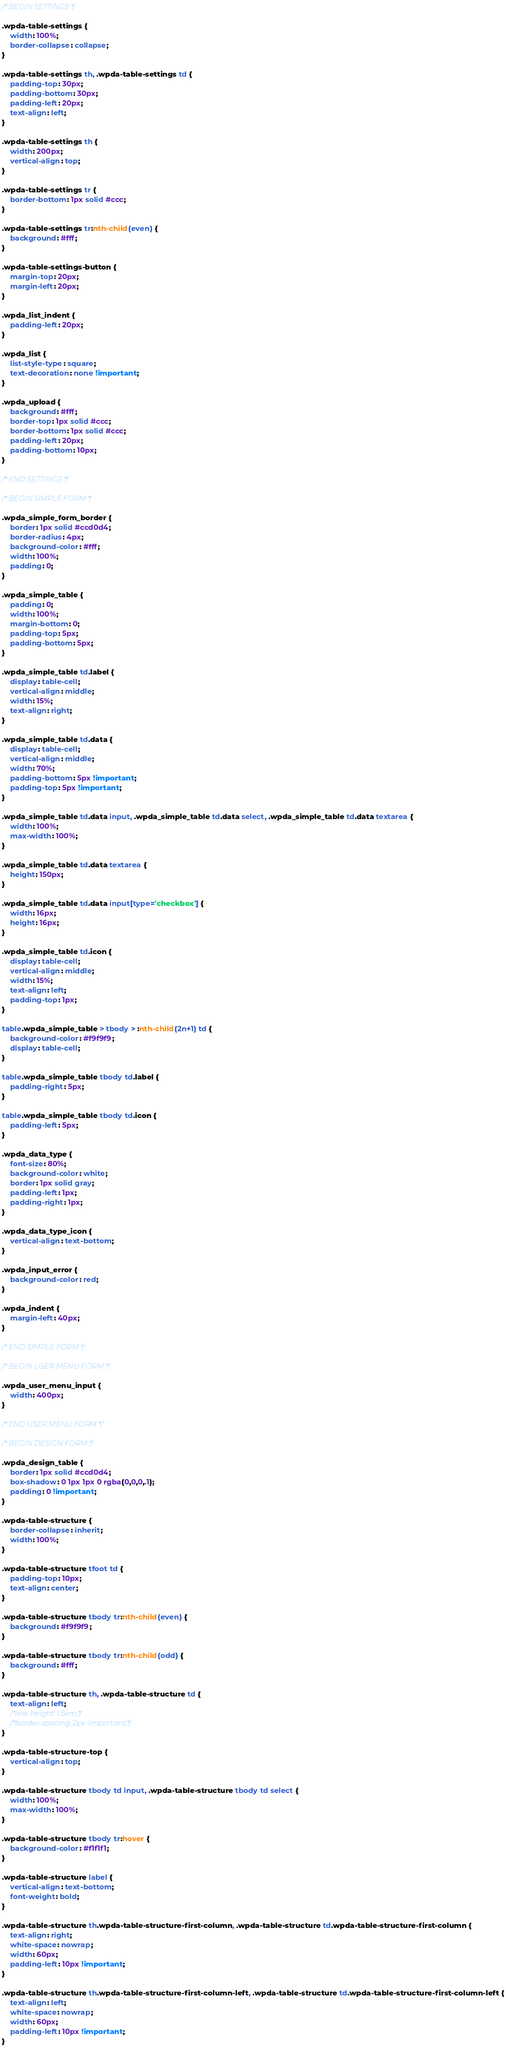Convert code to text. <code><loc_0><loc_0><loc_500><loc_500><_CSS_>/* BEGIN SETTINGS */

.wpda-table-settings {
    width: 100%;
    border-collapse: collapse;
}

.wpda-table-settings th, .wpda-table-settings td {
    padding-top: 30px;
    padding-bottom: 30px;
    padding-left: 20px;
    text-align: left;
}

.wpda-table-settings th {
    width: 200px;
    vertical-align: top;
}

.wpda-table-settings tr {
    border-bottom: 1px solid #ccc;
}

.wpda-table-settings tr:nth-child(even) {
    background: #fff;
}

.wpda-table-settings-button {
    margin-top: 20px;
    margin-left: 20px;
}

.wpda_list_indent {
    padding-left: 20px;
}

.wpda_list {
    list-style-type: square;
    text-decoration: none !important;
}

.wpda_upload {
    background: #fff;
    border-top: 1px solid #ccc;
    border-bottom: 1px solid #ccc;
    padding-left: 20px;
    padding-bottom: 10px;
}

/* END SETTINGS */

/* BEGIN SIMPLE FORM */

.wpda_simple_form_border {
    border: 1px solid #ccd0d4;
    border-radius: 4px;
    background-color: #fff;
    width: 100%;
    padding: 0;
}

.wpda_simple_table {
    padding: 0;
    width: 100%;
    margin-bottom: 0;
    padding-top: 5px;
    padding-bottom: 5px;
}

.wpda_simple_table td.label {
    display: table-cell;
    vertical-align: middle;
    width: 15%;
    text-align: right;
}

.wpda_simple_table td.data {
    display: table-cell;
    vertical-align: middle;
    width: 70%;
    padding-bottom: 5px !important;
    padding-top: 5px !important;
}

.wpda_simple_table td.data input, .wpda_simple_table td.data select, .wpda_simple_table td.data textarea {
    width: 100%;
    max-width: 100%;
}

.wpda_simple_table td.data textarea {
    height: 150px;
}

.wpda_simple_table td.data input[type='checkbox'] {
    width: 16px;
    height: 16px;
}

.wpda_simple_table td.icon {
    display: table-cell;
    vertical-align: middle;
    width: 15%;
    text-align: left;
    padding-top: 1px;
}

table.wpda_simple_table > tbody > :nth-child(2n+1) td {
    background-color: #f9f9f9;
    display: table-cell;
}

table.wpda_simple_table tbody td.label {
    padding-right: 5px;
}

table.wpda_simple_table tbody td.icon {
    padding-left: 5px;
}

.wpda_data_type {
    font-size: 80%;
    background-color: white;
    border: 1px solid gray;
    padding-left: 1px;
    padding-right: 1px;
}

.wpda_data_type_icon {
    vertical-align: text-bottom;
}

.wpda_input_error {
    background-color: red;
}

.wpda_indent {
    margin-left: 40px;
}

/* END SIMPLE FORM */

/* BEGIN USER MENU FORM */

.wpda_user_menu_input {
    width: 400px;
}

/* END USER MENU FORM */

/* BEGIN DESIGN FORM */

.wpda_design_table {
    border: 1px solid #ccd0d4;
    box-shadow: 0 1px 1px 0 rgba(0,0,0,.1);
    padding: 0 !important;
}

.wpda-table-structure {
    border-collapse: inherit;
    width: 100%;
}

.wpda-table-structure tfoot td {
    padding-top: 10px;
    text-align: center;
}

.wpda-table-structure tbody tr:nth-child(even) {
    background: #f9f9f9;
}

.wpda-table-structure tbody tr:nth-child(odd) {
    background: #fff;
}

.wpda-table-structure th, .wpda-table-structure td {
    text-align: left;
    /*line-height: 1.5em;*/
    /*border-spacing: 2px !important;*/
}

.wpda-table-structure-top {
    vertical-align: top;
}

.wpda-table-structure tbody td input, .wpda-table-structure tbody td select {
    width: 100%;
    max-width: 100%;
}

.wpda-table-structure tbody tr:hover {
    background-color: #f1f1f1;
}

.wpda-table-structure label {
    vertical-align: text-bottom;
    font-weight: bold;
}

.wpda-table-structure th.wpda-table-structure-first-column, .wpda-table-structure td.wpda-table-structure-first-column {
    text-align: right;
    white-space: nowrap;
    width: 60px;
    padding-left: 10px !important;
}

.wpda-table-structure th.wpda-table-structure-first-column-left, .wpda-table-structure td.wpda-table-structure-first-column-left {
    text-align: left;
    white-space: nowrap;
    width: 60px;
    padding-left: 10px !important;
}
</code> 